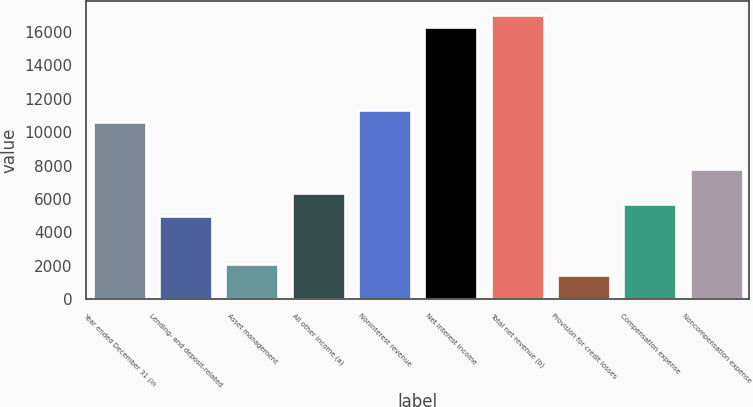Convert chart to OTSL. <chart><loc_0><loc_0><loc_500><loc_500><bar_chart><fcel>Year ended December 31 (in<fcel>Lending- and deposit-related<fcel>Asset management<fcel>All other income (a)<fcel>Noninterest revenue<fcel>Net interest income<fcel>Total net revenue (b)<fcel>Provision for credit losses<fcel>Compensation expense<fcel>Noncompensation expense<nl><fcel>10628.5<fcel>4970.1<fcel>2140.9<fcel>6384.7<fcel>11335.8<fcel>16286.9<fcel>16994.2<fcel>1433.6<fcel>5677.4<fcel>7799.3<nl></chart> 